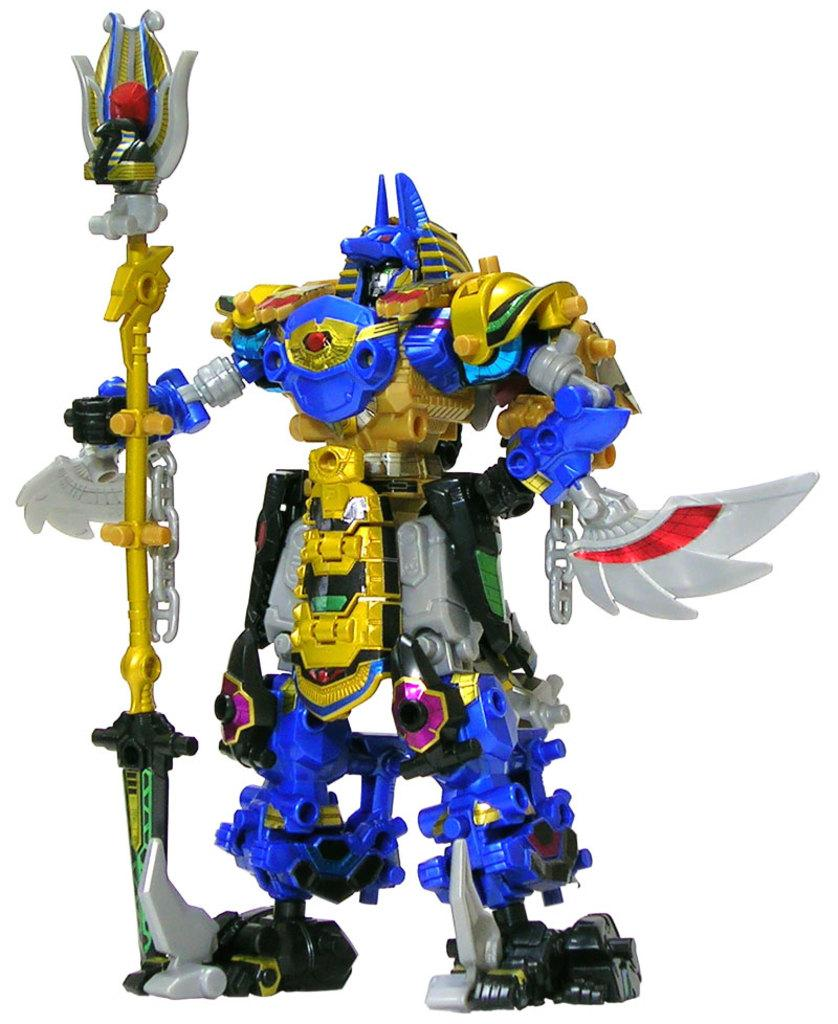What can be seen in the image? There is a toy in the image. What is the toy doing in the image? The toy is holding an object in its hand. What type of powder is the writer using in the image? There is no writer or powder present in the image; it only features a toy holding an object. 